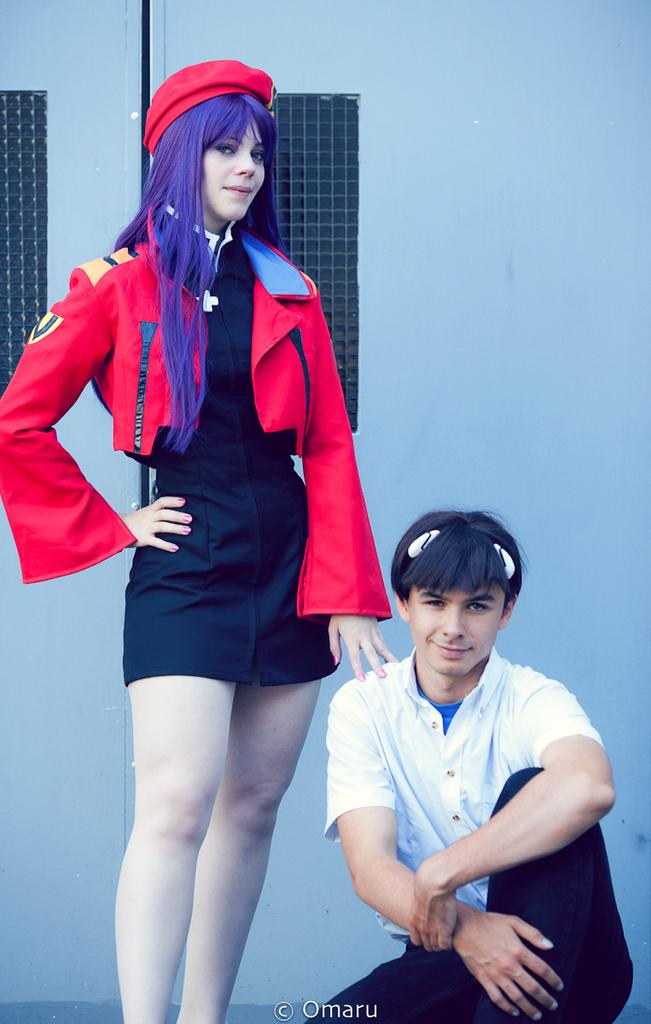How many people are in the image? There are two persons in the image. What are the persons doing in the image? The persons are on the floor. What can be seen in the background of the image? There are windows and a wall in the background of the image. Can you describe the lighting in the image? The image was likely taken during the day, as there is sufficient natural light. What type of hose is being used by the persons in the image? There is no hose present in the image; the persons are on the floor. Can you tell me how many street signs are visible in the image? There is no street or street signs visible in the image. 